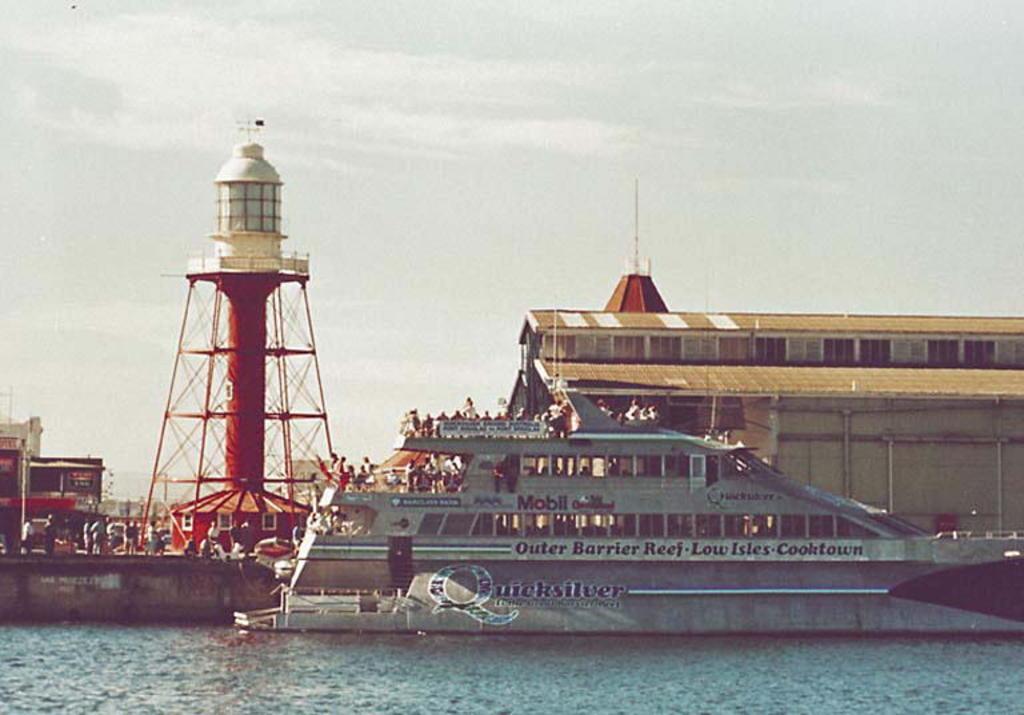What is the brand of this boat?
Keep it short and to the point. Quicksilver. What reef is noted on the side of the boat?
Provide a short and direct response. Outer barrier reef. 